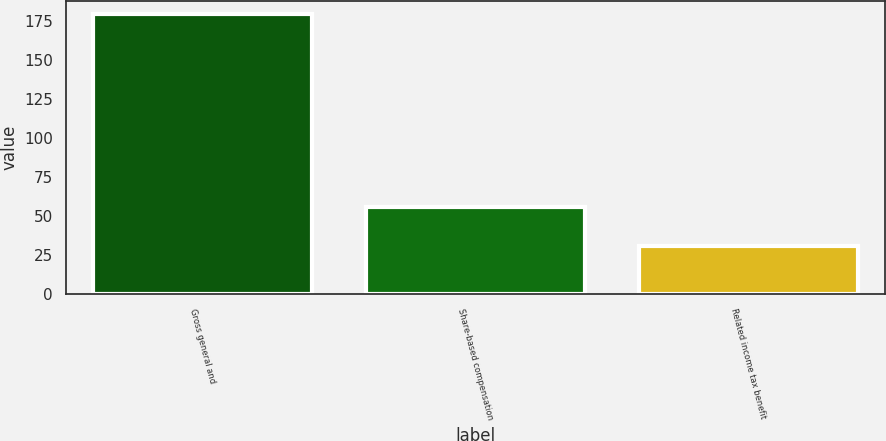Convert chart. <chart><loc_0><loc_0><loc_500><loc_500><bar_chart><fcel>Gross general and<fcel>Share-based compensation<fcel>Related income tax benefit<nl><fcel>179<fcel>56<fcel>31<nl></chart> 